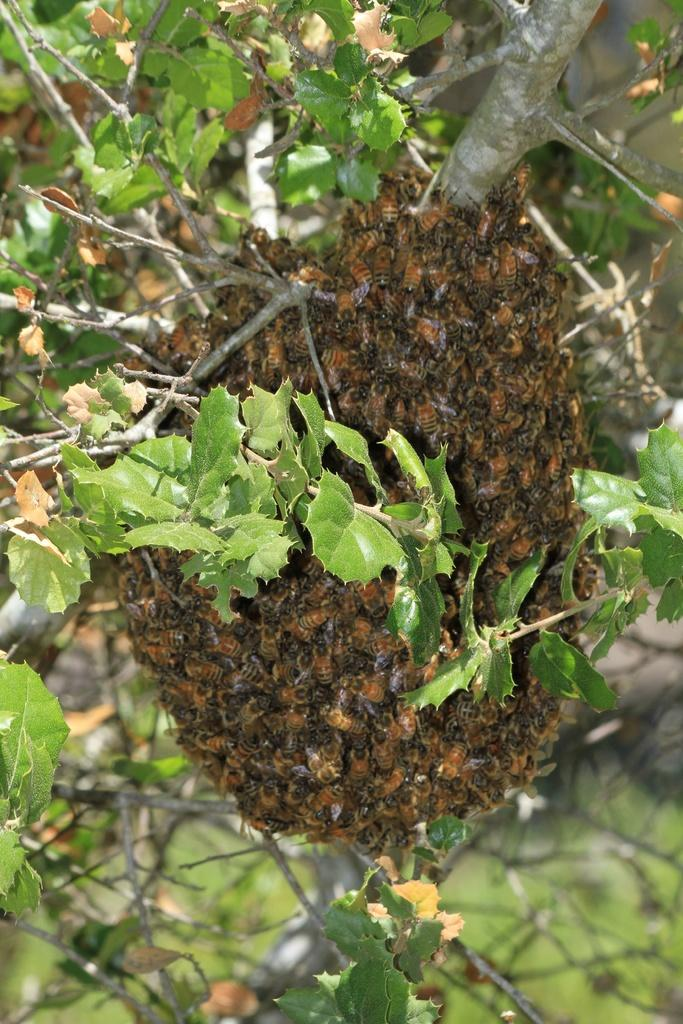What is the main subject of the image? The main subject of the image is a swarm of bees. Where are the bees going in the image? The bees are going to a tree in the image. What type of wren can be seen sitting on the notebook in the image? There is no wren or notebook present in the image; it only features a swarm of bees going to a tree. 